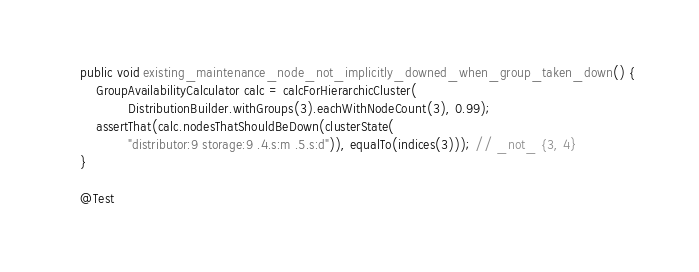<code> <loc_0><loc_0><loc_500><loc_500><_Java_>    public void existing_maintenance_node_not_implicitly_downed_when_group_taken_down() {
        GroupAvailabilityCalculator calc = calcForHierarchicCluster(
                DistributionBuilder.withGroups(3).eachWithNodeCount(3), 0.99);
        assertThat(calc.nodesThatShouldBeDown(clusterState(
                "distributor:9 storage:9 .4.s:m .5.s:d")), equalTo(indices(3))); // _not_ {3, 4}
    }

    @Test</code> 